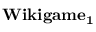<formula> <loc_0><loc_0><loc_500><loc_500>W i k i g a m e _ { 1 }</formula> 